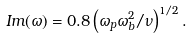Convert formula to latex. <formula><loc_0><loc_0><loc_500><loc_500>I m ( \omega ) = 0 . 8 \left ( \omega _ { p } \omega _ { b } ^ { 2 } / \nu \right ) ^ { 1 / 2 } .</formula> 